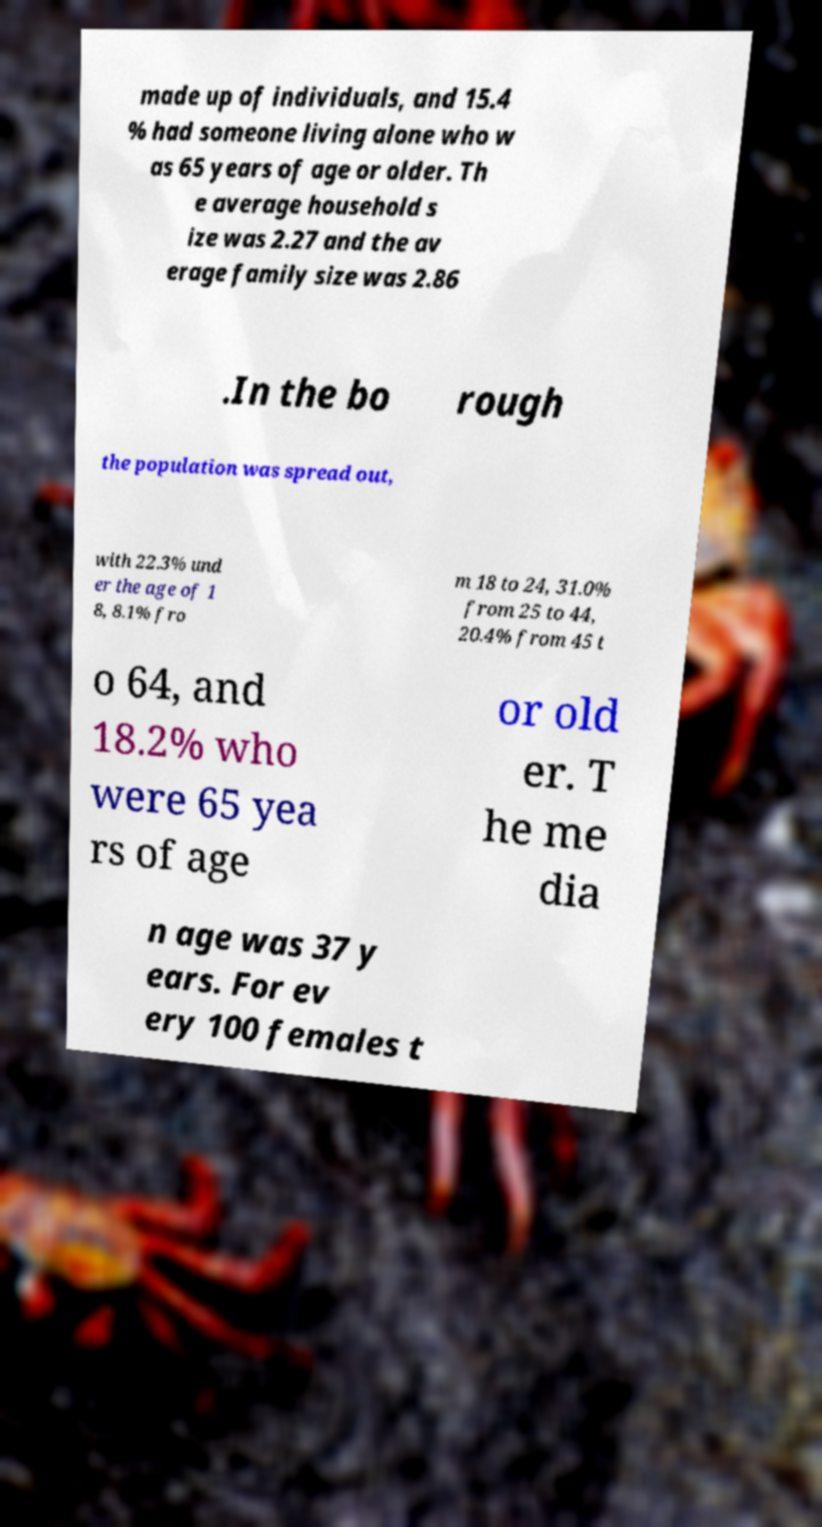I need the written content from this picture converted into text. Can you do that? made up of individuals, and 15.4 % had someone living alone who w as 65 years of age or older. Th e average household s ize was 2.27 and the av erage family size was 2.86 .In the bo rough the population was spread out, with 22.3% und er the age of 1 8, 8.1% fro m 18 to 24, 31.0% from 25 to 44, 20.4% from 45 t o 64, and 18.2% who were 65 yea rs of age or old er. T he me dia n age was 37 y ears. For ev ery 100 females t 